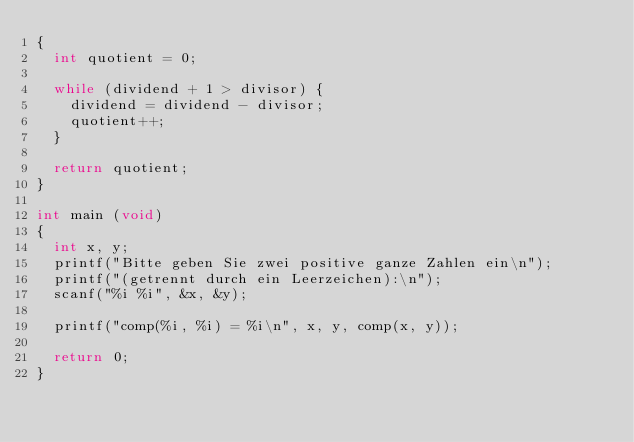Convert code to text. <code><loc_0><loc_0><loc_500><loc_500><_C_>{
  int quotient = 0;

  while (dividend + 1 > divisor) {
    dividend = dividend - divisor;
    quotient++;
  }

  return quotient;
}

int main (void)
{
  int x, y;
  printf("Bitte geben Sie zwei positive ganze Zahlen ein\n");
  printf("(getrennt durch ein Leerzeichen):\n");
  scanf("%i %i", &x, &y);

  printf("comp(%i, %i) = %i\n", x, y, comp(x, y));

  return 0;
}
</code> 